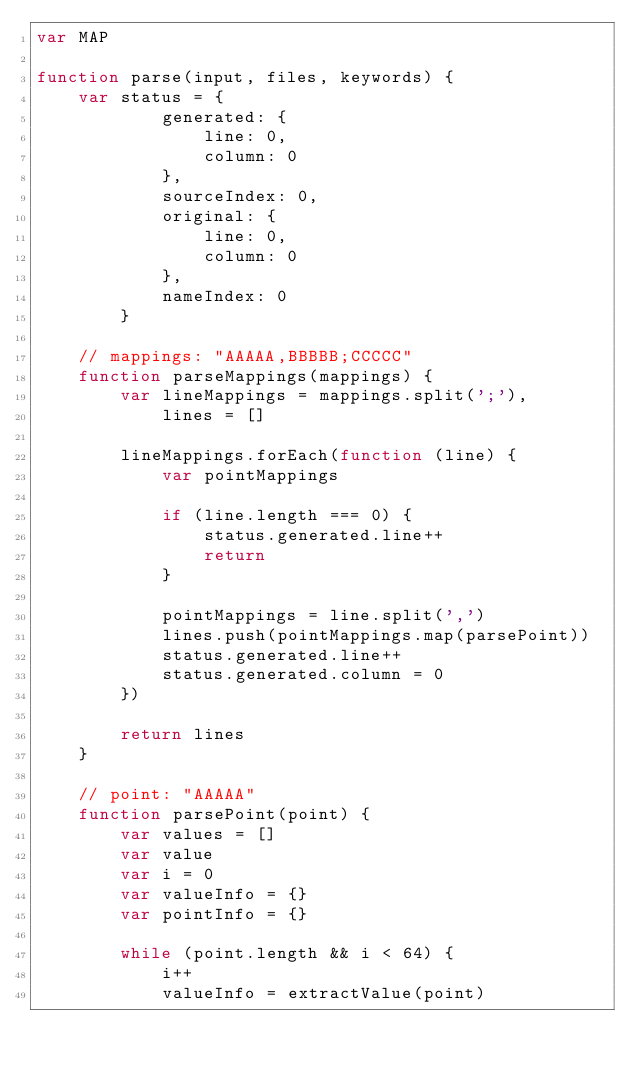<code> <loc_0><loc_0><loc_500><loc_500><_JavaScript_>var MAP

function parse(input, files, keywords) {
    var status = {
            generated: {
                line: 0,
                column: 0
            },
            sourceIndex: 0,
            original: {
                line: 0,
                column: 0
            },
            nameIndex: 0
        }

    // mappings: "AAAAA,BBBBB;CCCCC"
    function parseMappings(mappings) {
        var lineMappings = mappings.split(';'),
            lines = []

        lineMappings.forEach(function (line) {
            var pointMappings

            if (line.length === 0) {
                status.generated.line++
                return
            }

            pointMappings = line.split(',')
            lines.push(pointMappings.map(parsePoint))
            status.generated.line++
            status.generated.column = 0
        })

        return lines
    }

    // point: "AAAAA"
    function parsePoint(point) {
        var values = []
        var value
        var i = 0
        var valueInfo = {}
        var pointInfo = {}

        while (point.length && i < 64) {
            i++
            valueInfo = extractValue(point)</code> 